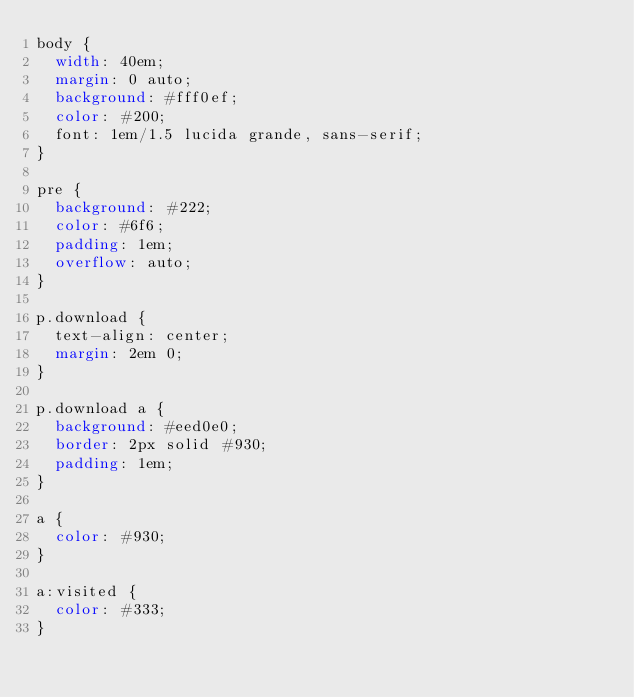<code> <loc_0><loc_0><loc_500><loc_500><_CSS_>body {
  width: 40em;
  margin: 0 auto;
  background: #fff0ef;
  color: #200;
  font: 1em/1.5 lucida grande, sans-serif;
}

pre {
  background: #222;
  color: #6f6;
  padding: 1em;
  overflow: auto;
}

p.download {
  text-align: center;
  margin: 2em 0;
}

p.download a {
  background: #eed0e0;
  border: 2px solid #930;
  padding: 1em;
}

a {
  color: #930;
}

a:visited {
  color: #333;
}</code> 